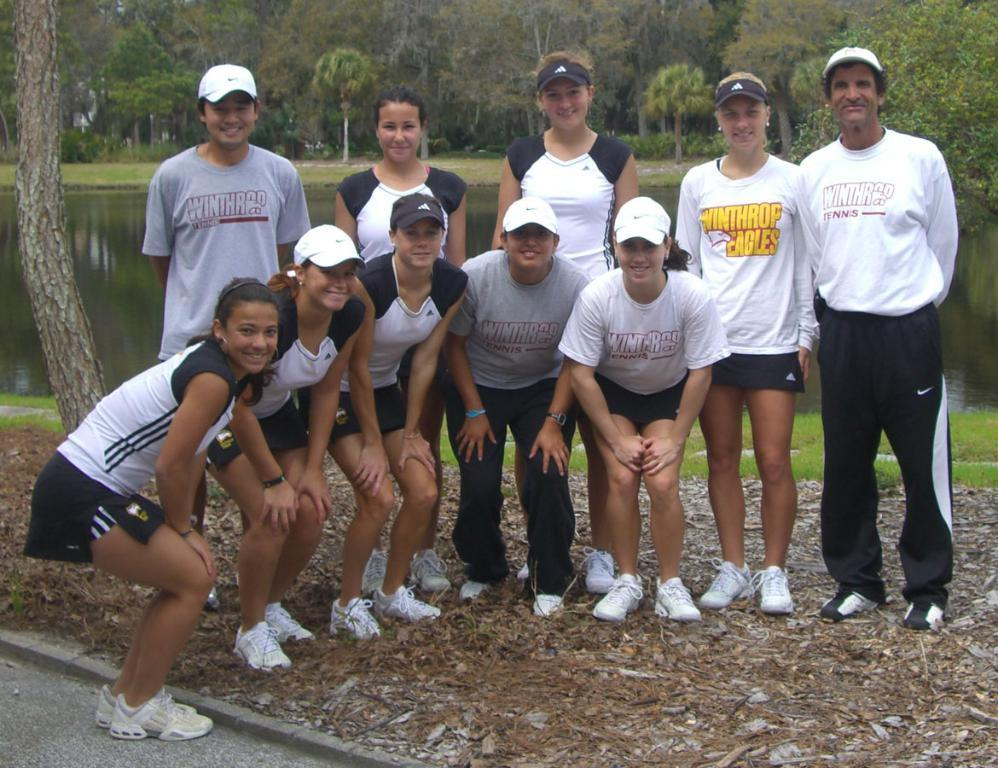How many people are in the image? There is a group of people in the image. What are the people doing in the image? The people are standing and smiling. What type of terrain is visible in the image? There is grass and water visible in the image. What can be seen in the background of the image? There are trees in the background of the image. What type of coast can be seen in the image? There is no coast visible in the image; it features a group of people standing and smiling in a grassy area with water and trees in the background. How many snakes are slithering through the grass in the image? There are no snakes present in the image; it features a group of people standing and smiling in a grassy area with water and trees in the background. 